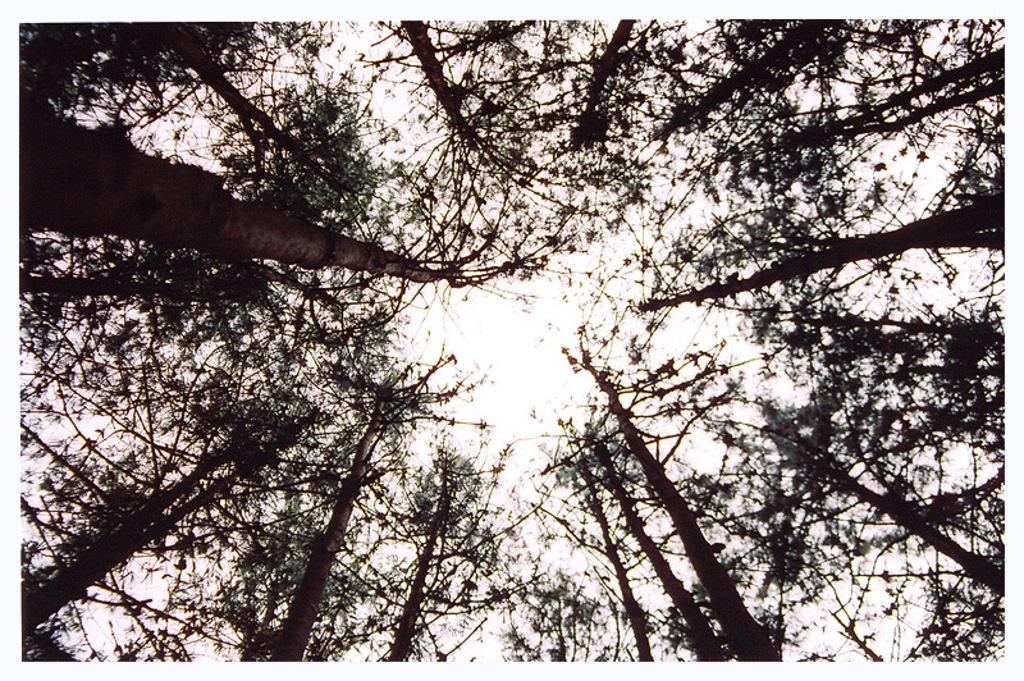What type of vegetation can be seen in the image? There are trees in the image. What part of the natural environment is visible in the image? The sky is visible in the background of the image. Where is the harbor located in the image? There is no harbor present in the image; it only features trees and the sky. Can you tell me how many basketballs are visible in the image? There are no basketballs present in the image. 